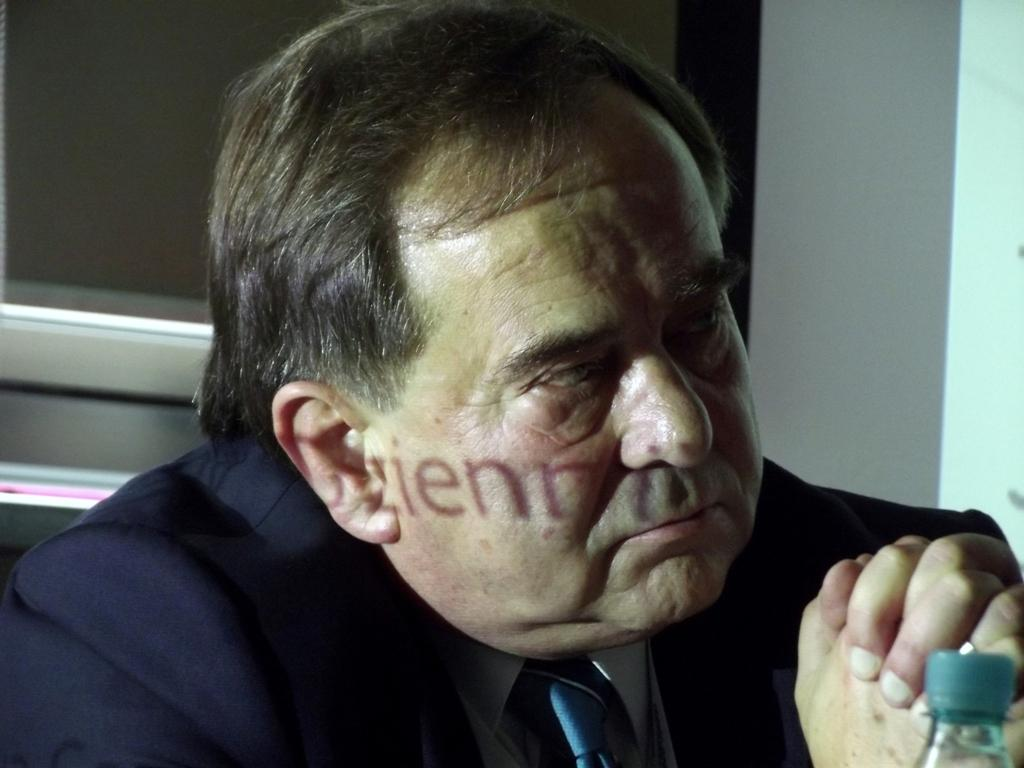Who is present in the image? There is a man in the image. What is the man doing in the image? The man is sitting at a table in the image. What is the man wearing in the image? The man is wearing a blue suit in the image. What object is in front of the man? There is a bottle in front of the man in the image. What reward does the man receive for his work as a carpenter in the image? There is no indication in the image that the man is a carpenter or that he is receiving any reward for his work. 